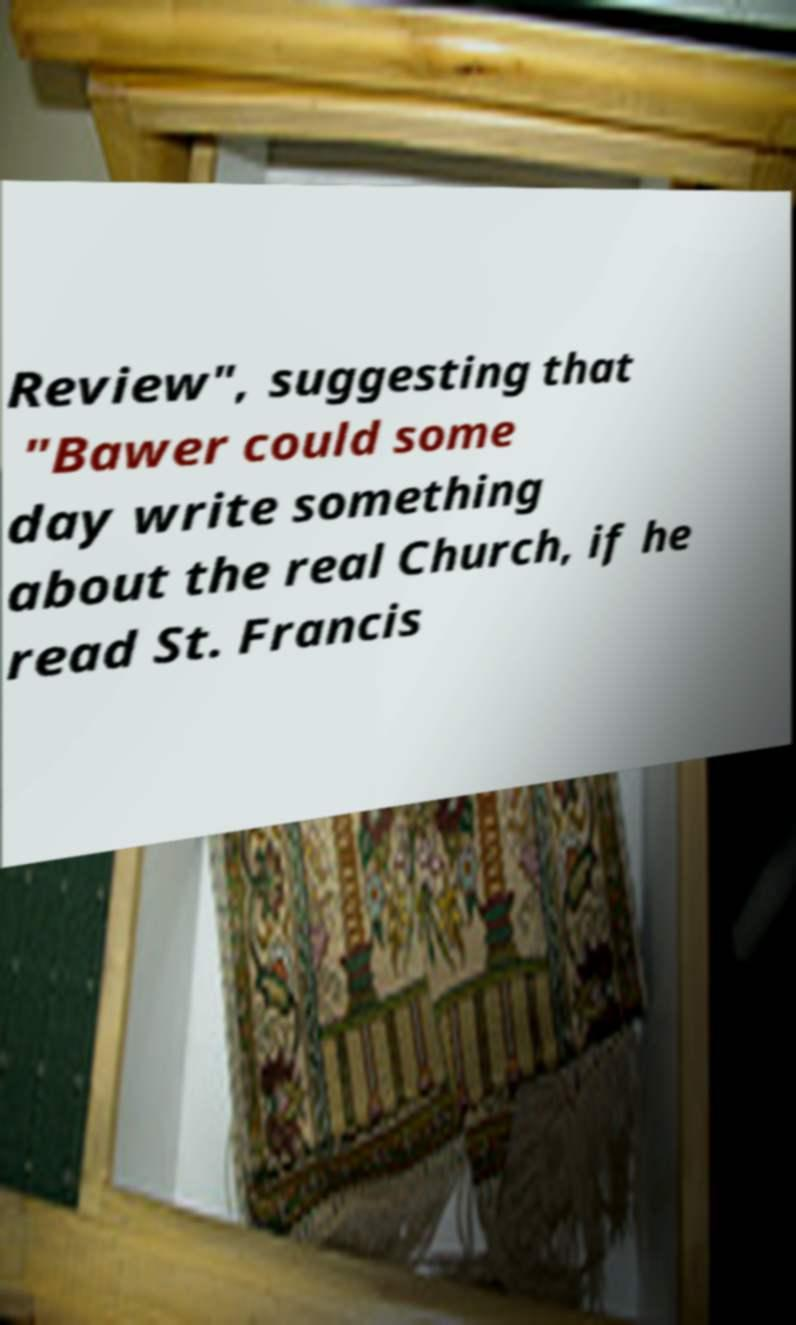What messages or text are displayed in this image? I need them in a readable, typed format. Review", suggesting that "Bawer could some day write something about the real Church, if he read St. Francis 